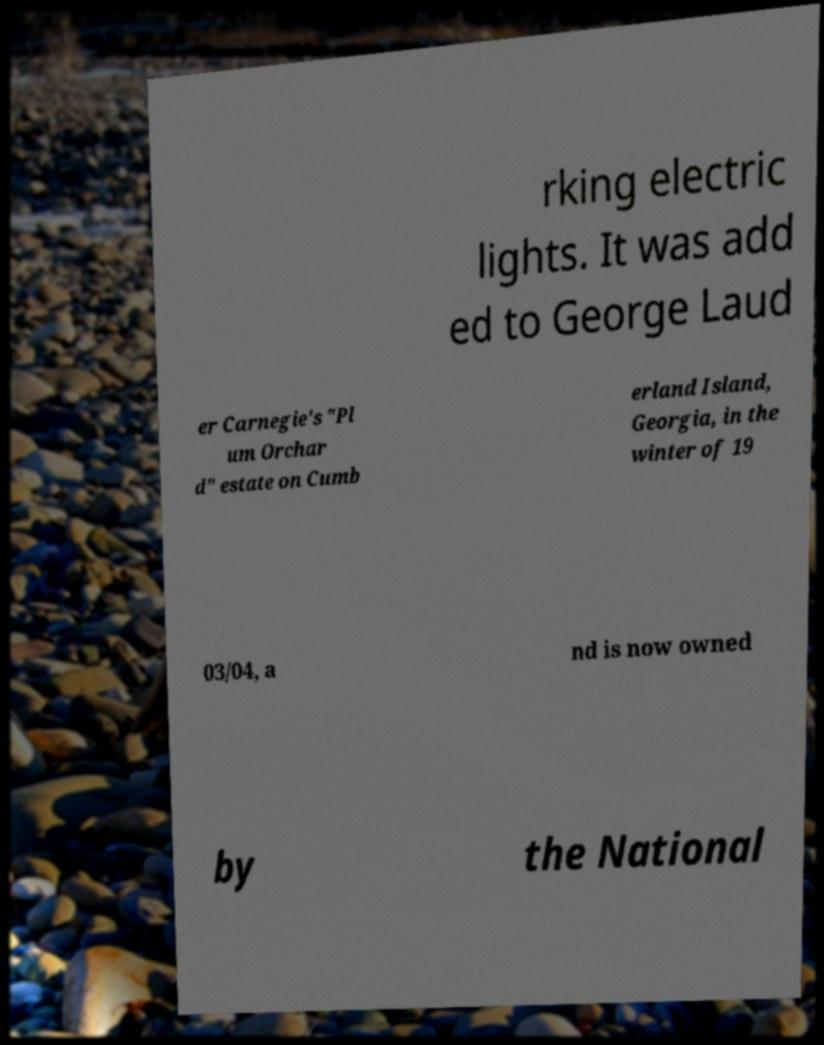I need the written content from this picture converted into text. Can you do that? rking electric lights. It was add ed to George Laud er Carnegie's "Pl um Orchar d" estate on Cumb erland Island, Georgia, in the winter of 19 03/04, a nd is now owned by the National 